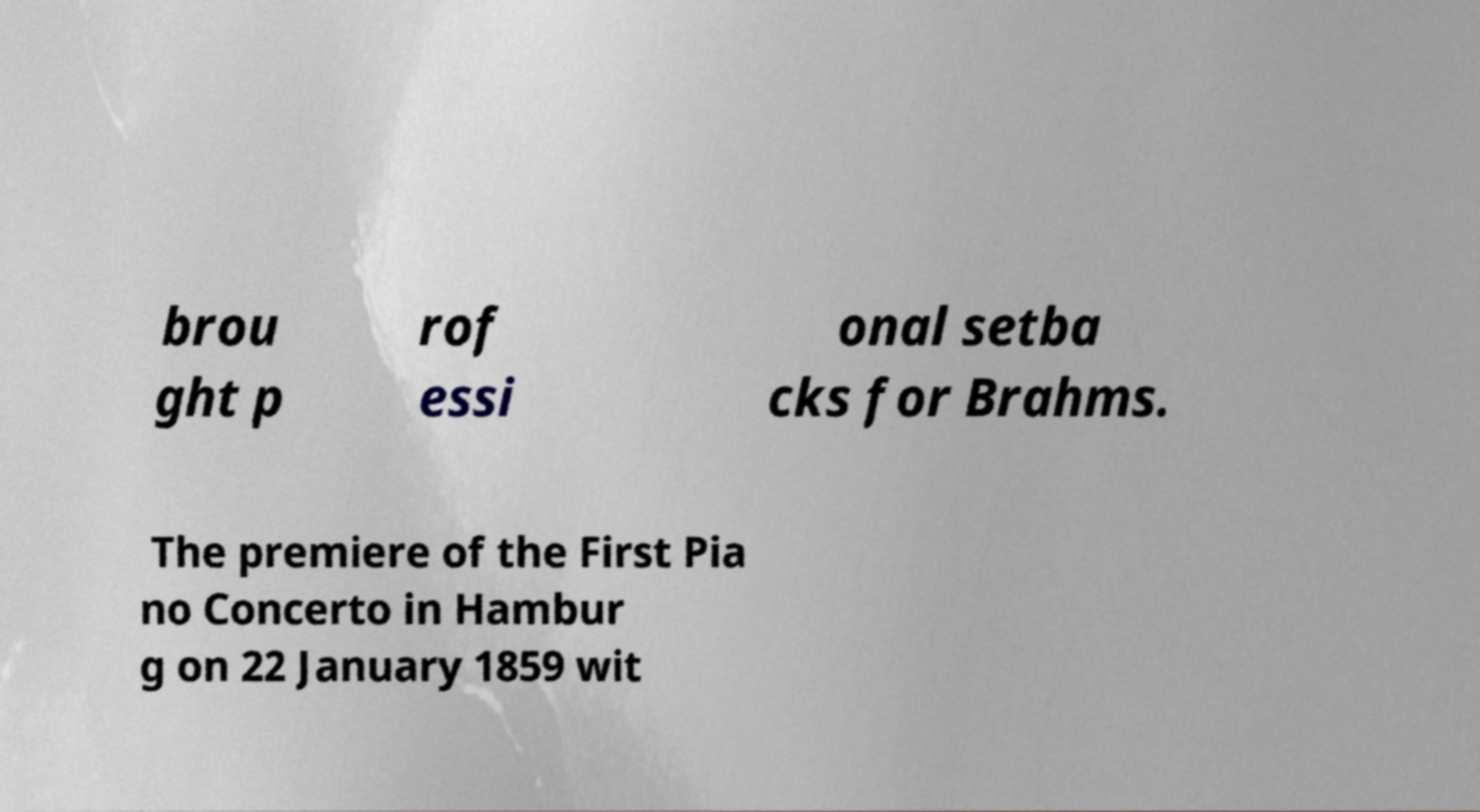Can you read and provide the text displayed in the image?This photo seems to have some interesting text. Can you extract and type it out for me? brou ght p rof essi onal setba cks for Brahms. The premiere of the First Pia no Concerto in Hambur g on 22 January 1859 wit 